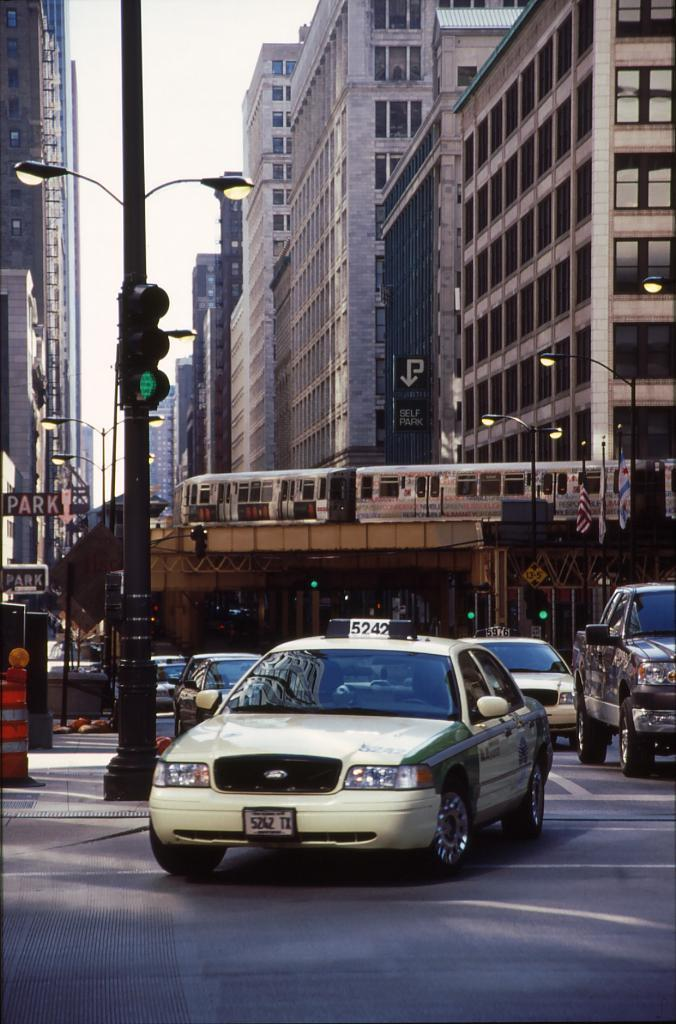<image>
Offer a succinct explanation of the picture presented. A white taxi is taking a turn at an intersection with a sign that says Park. 